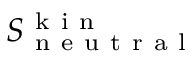<formula> <loc_0><loc_0><loc_500><loc_500>S _ { n e u t r a l } ^ { k i n }</formula> 